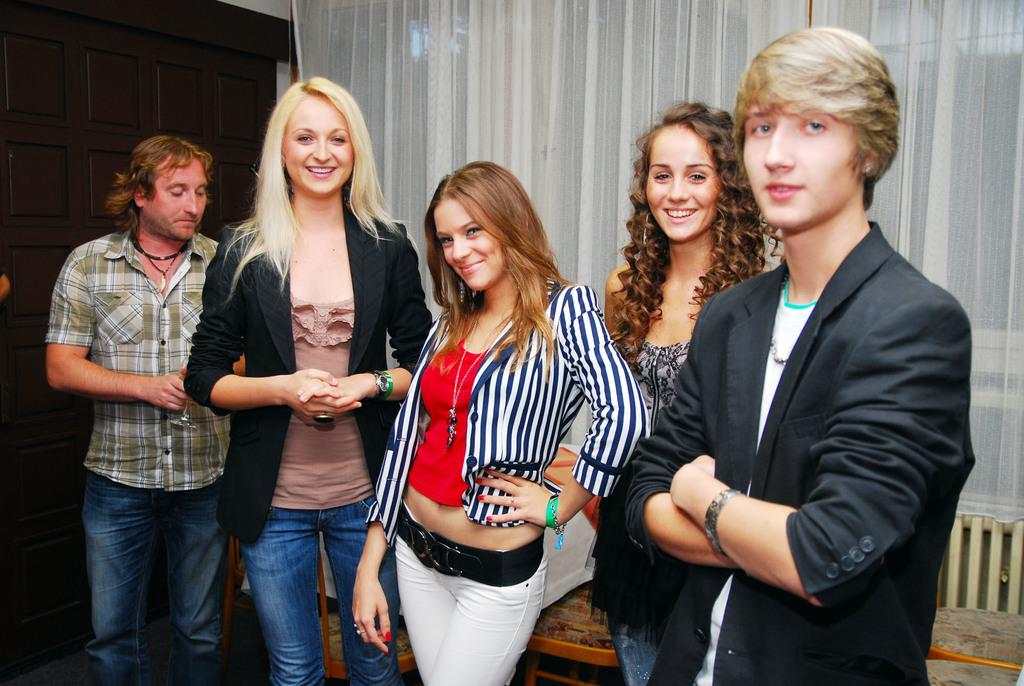How many individuals are present in the image? There are five people in the image. Can you describe the gender distribution among the people? Three of the people are women, and two of the people are men. What can be seen in the background of the image? There are curtains in the background of the image. What type of road can be seen in the image? There is no road present in the image; it features a group of people and curtains in the background. What record is being played in the image? There is no record being played in the image; it only shows a group of people and curtains in the background. 